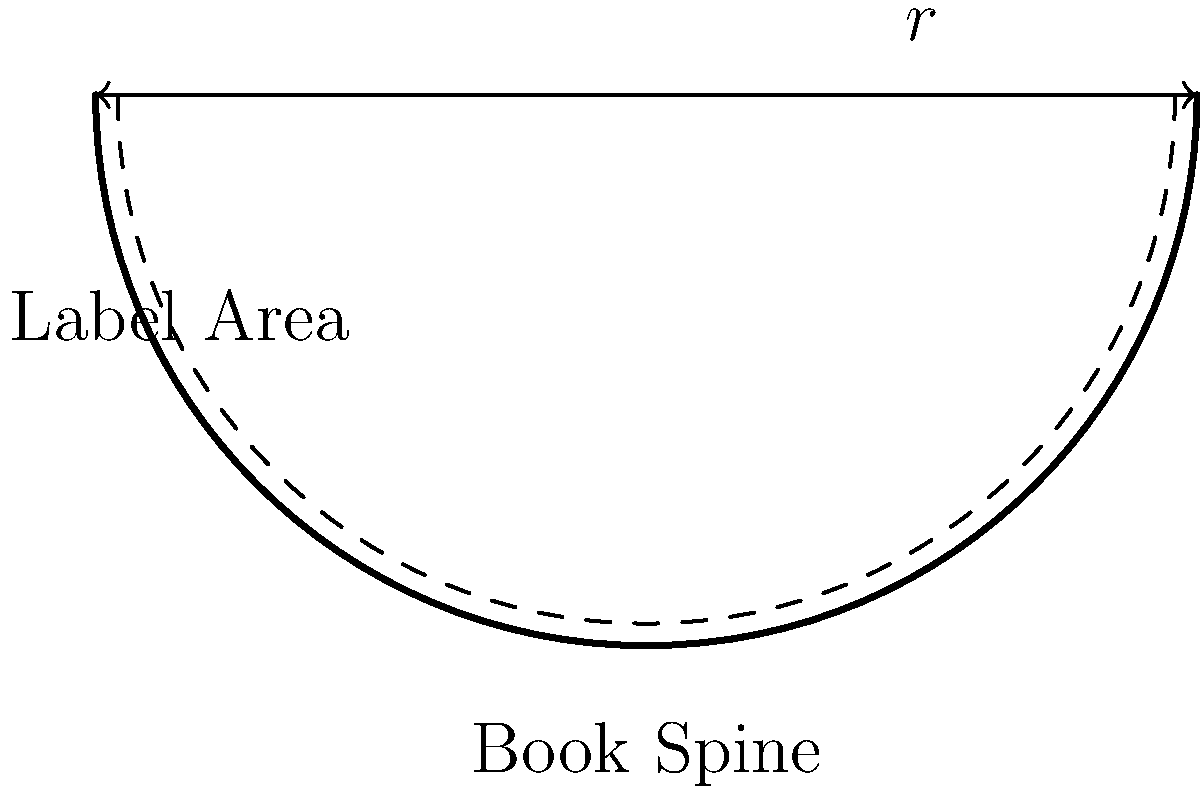As a digital librarian, you're designing a labeling system for curved book spines. If a book spine has a radius of curvature $r$ and the label needs to cover an arc length of $\frac{\pi r}{2}$, what is the central angle $\theta$ (in degrees) that the label subtends? Let's approach this step-by-step:

1) The formula for arc length $s$ is given by:
   $$s = r\theta$$
   where $r$ is the radius and $\theta$ is the central angle in radians.

2) We're given that the arc length $s = \frac{\pi r}{2}$, so we can substitute this:
   $$\frac{\pi r}{2} = r\theta$$

3) Dividing both sides by $r$:
   $$\frac{\pi}{2} = \theta$$

4) This gives us the angle in radians. To convert to degrees, we multiply by $\frac{180°}{\pi}$:
   $$\theta_{degrees} = \frac{\pi}{2} \cdot \frac{180°}{\pi} = 90°$$

Therefore, the central angle subtended by the label is 90°.
Answer: 90° 